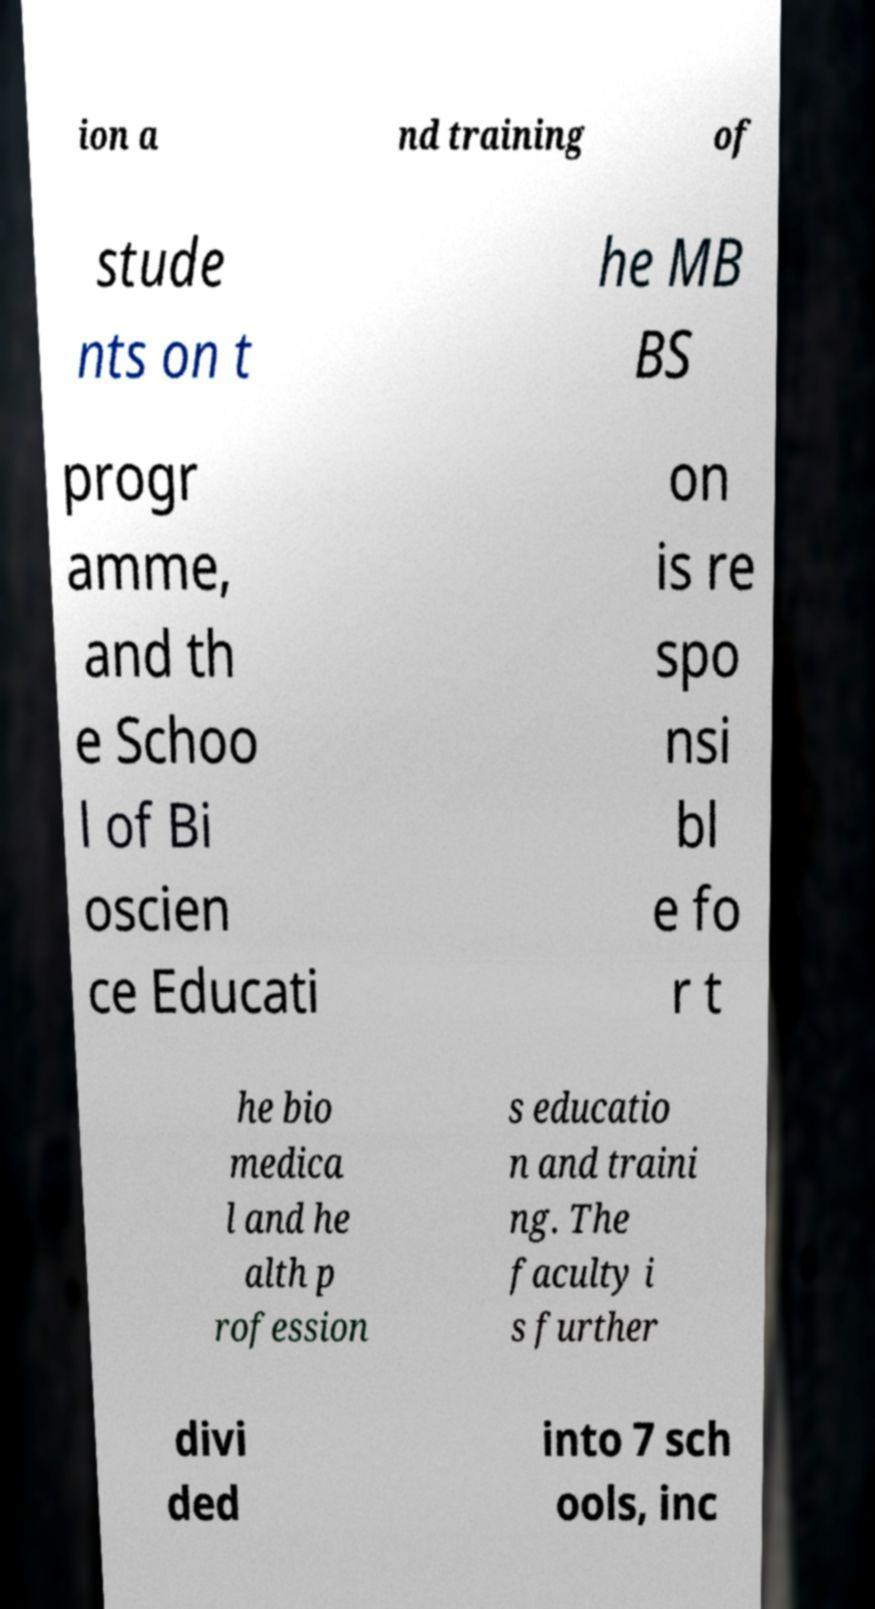Please read and relay the text visible in this image. What does it say? ion a nd training of stude nts on t he MB BS progr amme, and th e Schoo l of Bi oscien ce Educati on is re spo nsi bl e fo r t he bio medica l and he alth p rofession s educatio n and traini ng. The faculty i s further divi ded into 7 sch ools, inc 